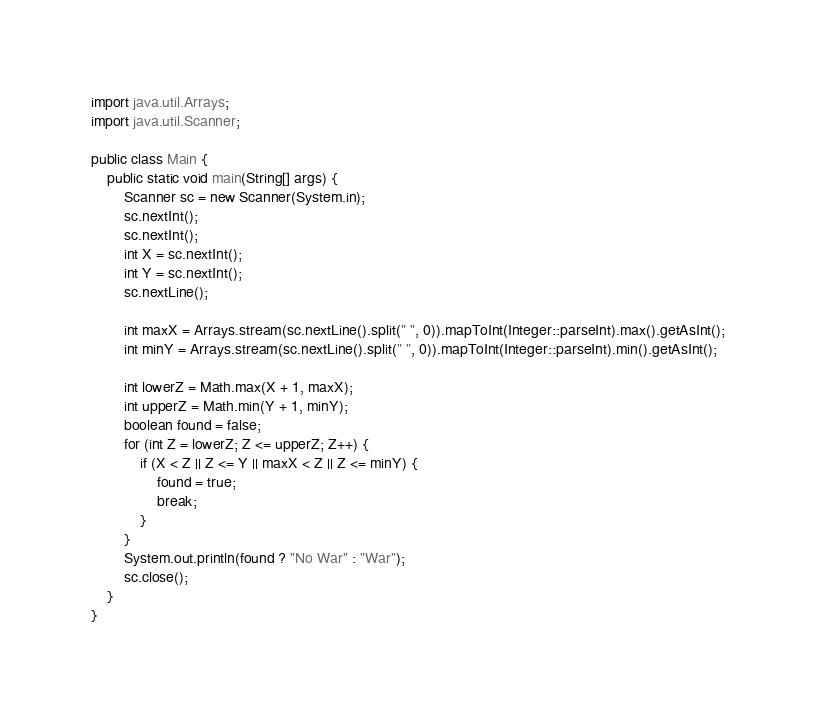<code> <loc_0><loc_0><loc_500><loc_500><_Java_>import java.util.Arrays;
import java.util.Scanner;

public class Main {
	public static void main(String[] args) {
		Scanner sc = new Scanner(System.in);
		sc.nextInt();
		sc.nextInt();
		int X = sc.nextInt();
		int Y = sc.nextInt();
		sc.nextLine();

		int maxX = Arrays.stream(sc.nextLine().split(" ", 0)).mapToInt(Integer::parseInt).max().getAsInt();
		int minY = Arrays.stream(sc.nextLine().split(" ", 0)).mapToInt(Integer::parseInt).min().getAsInt();

		int lowerZ = Math.max(X + 1, maxX);
		int upperZ = Math.min(Y + 1, minY);
		boolean found = false;
		for (int Z = lowerZ; Z <= upperZ; Z++) {
			if (X < Z || Z <= Y || maxX < Z || Z <= minY) {
				found = true;
				break;
			}
		}
		System.out.println(found ? "No War" : "War");
		sc.close();
	}
}</code> 